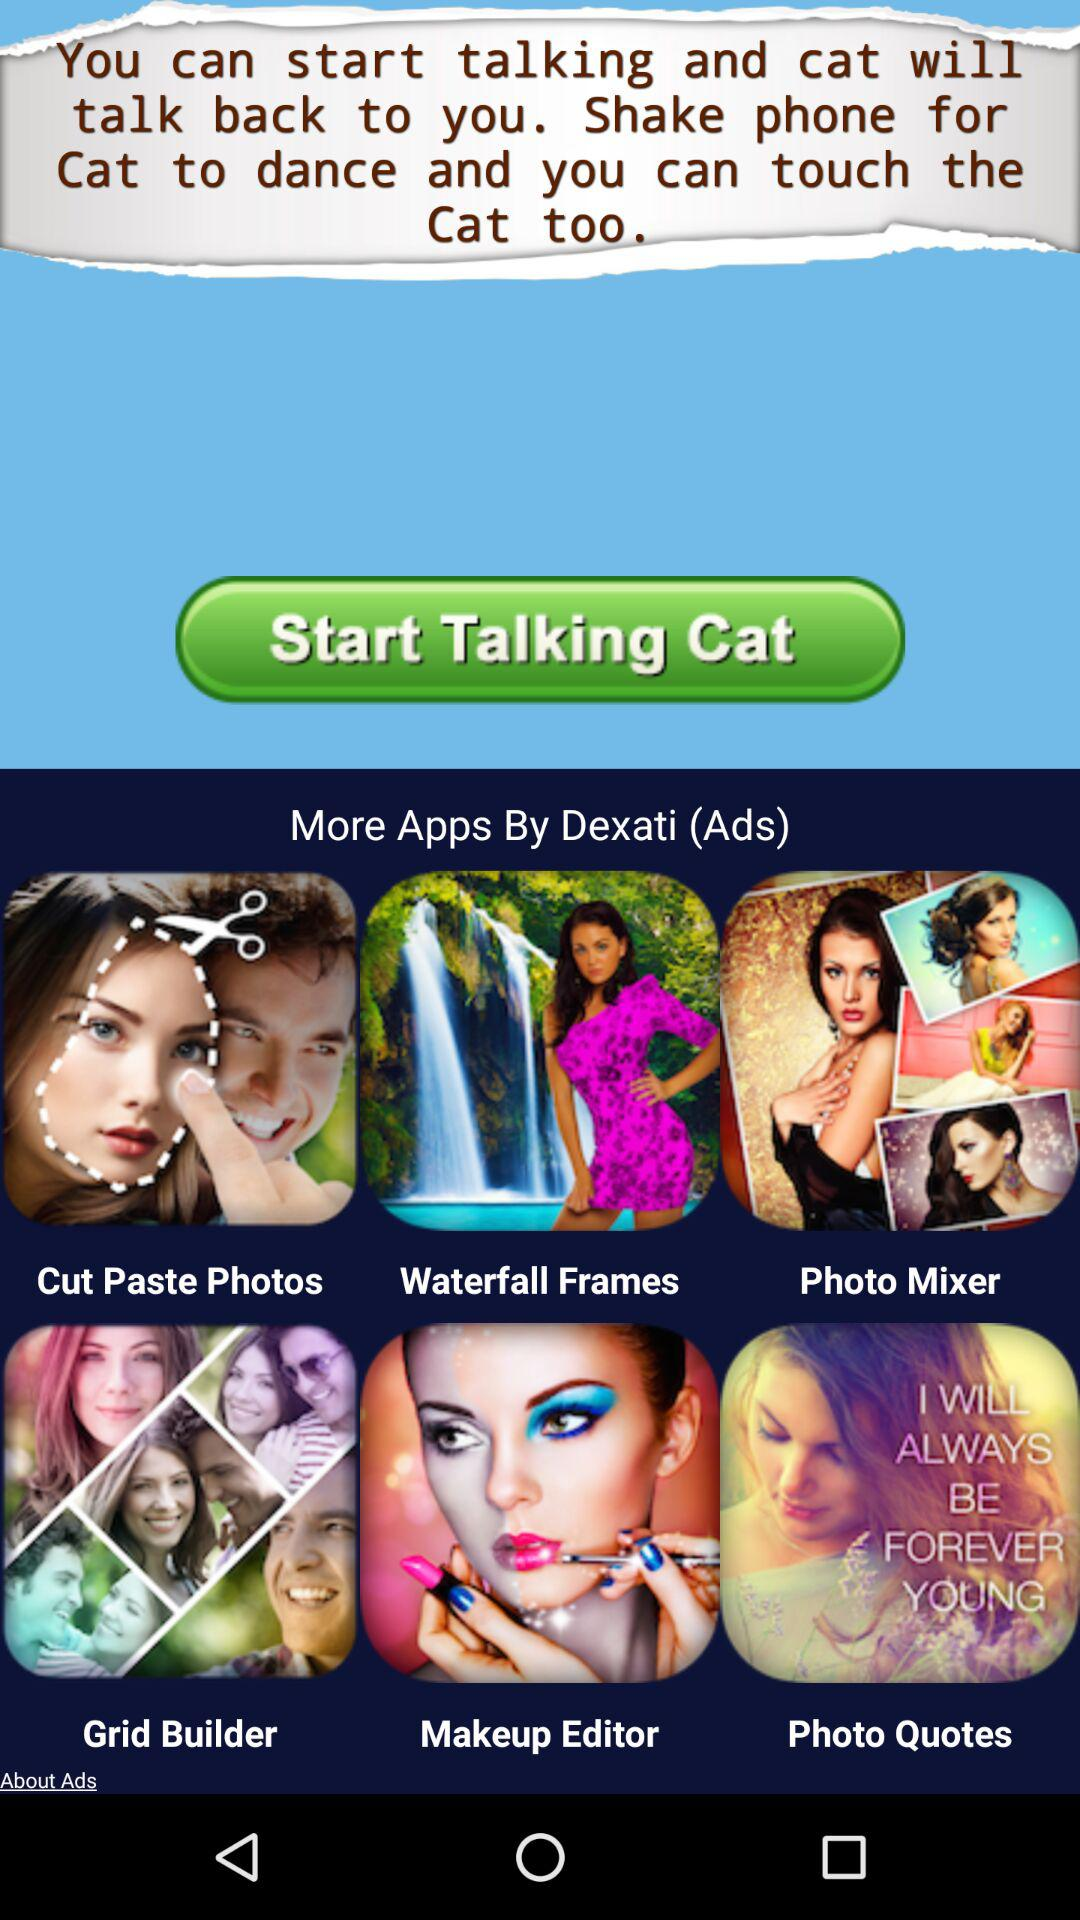What is the application name? The application name is "Talking Cat". 